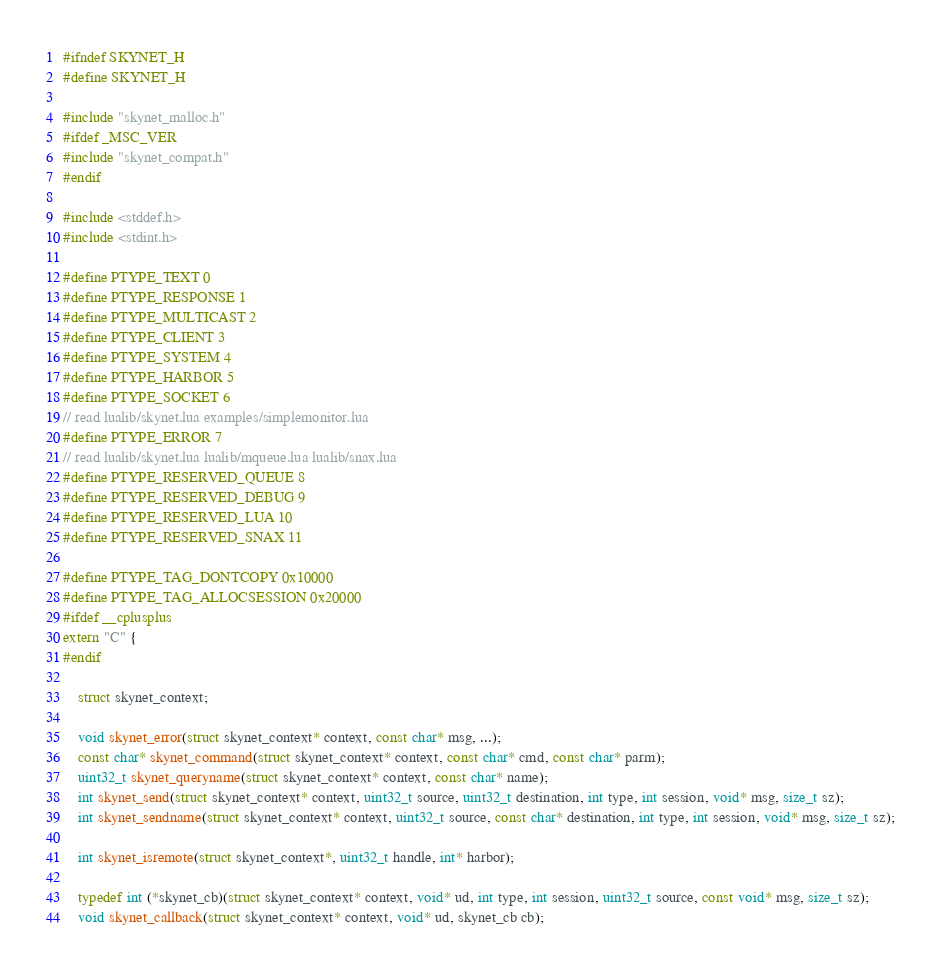Convert code to text. <code><loc_0><loc_0><loc_500><loc_500><_C_>#ifndef SKYNET_H
#define SKYNET_H

#include "skynet_malloc.h"
#ifdef _MSC_VER
#include "skynet_compat.h"
#endif

#include <stddef.h>
#include <stdint.h>

#define PTYPE_TEXT 0
#define PTYPE_RESPONSE 1
#define PTYPE_MULTICAST 2
#define PTYPE_CLIENT 3
#define PTYPE_SYSTEM 4
#define PTYPE_HARBOR 5
#define PTYPE_SOCKET 6
// read lualib/skynet.lua examples/simplemonitor.lua
#define PTYPE_ERROR 7	
// read lualib/skynet.lua lualib/mqueue.lua lualib/snax.lua
#define PTYPE_RESERVED_QUEUE 8
#define PTYPE_RESERVED_DEBUG 9
#define PTYPE_RESERVED_LUA 10
#define PTYPE_RESERVED_SNAX 11

#define PTYPE_TAG_DONTCOPY 0x10000
#define PTYPE_TAG_ALLOCSESSION 0x20000
#ifdef __cplusplus 
extern "C" {
#endif

	struct skynet_context;

	void skynet_error(struct skynet_context* context, const char* msg, ...);
	const char* skynet_command(struct skynet_context* context, const char* cmd, const char* parm);
	uint32_t skynet_queryname(struct skynet_context* context, const char* name);
	int skynet_send(struct skynet_context* context, uint32_t source, uint32_t destination, int type, int session, void* msg, size_t sz);
	int skynet_sendname(struct skynet_context* context, uint32_t source, const char* destination, int type, int session, void* msg, size_t sz);

	int skynet_isremote(struct skynet_context*, uint32_t handle, int* harbor);

	typedef int (*skynet_cb)(struct skynet_context* context, void* ud, int type, int session, uint32_t source, const void* msg, size_t sz);
	void skynet_callback(struct skynet_context* context, void* ud, skynet_cb cb);
</code> 